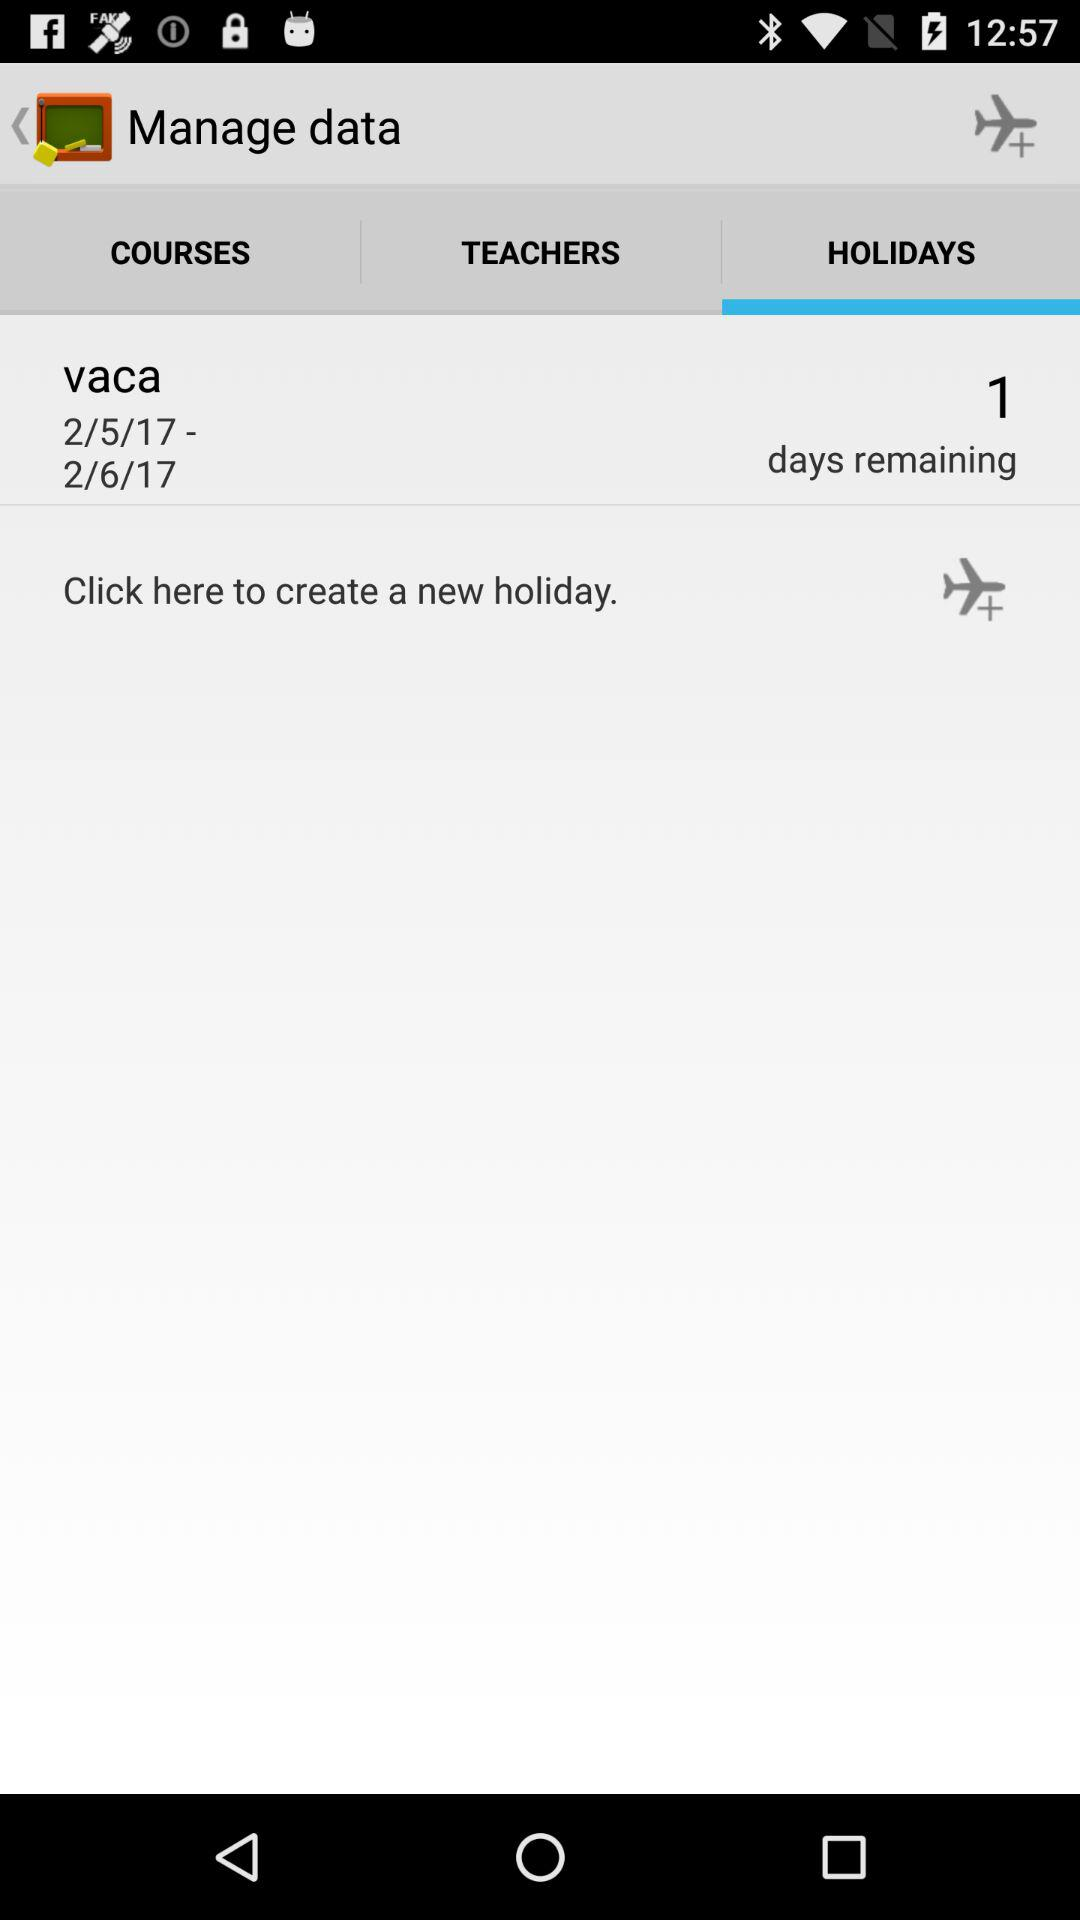What are the selected dates? The selected dates are 2/5/17 to 2/6/17. 